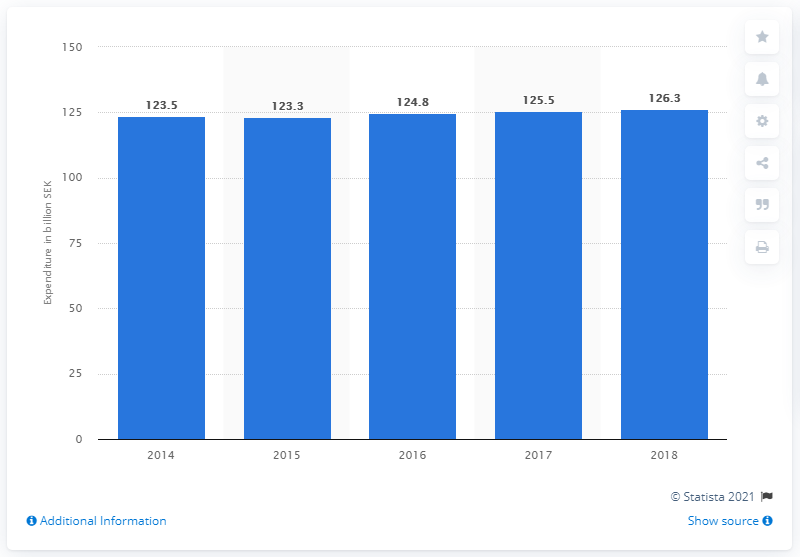Outline some significant characteristics in this image. In 2018, a total of 126.3 million Swedish kronor was spent on elderly care. 